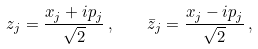Convert formula to latex. <formula><loc_0><loc_0><loc_500><loc_500>z _ { j } = \frac { x _ { j } + i p _ { j } } { \sqrt { 2 } } \, , \quad \bar { z } _ { j } = \frac { x _ { j } - i p _ { j } } { \sqrt { 2 } } \, ,</formula> 